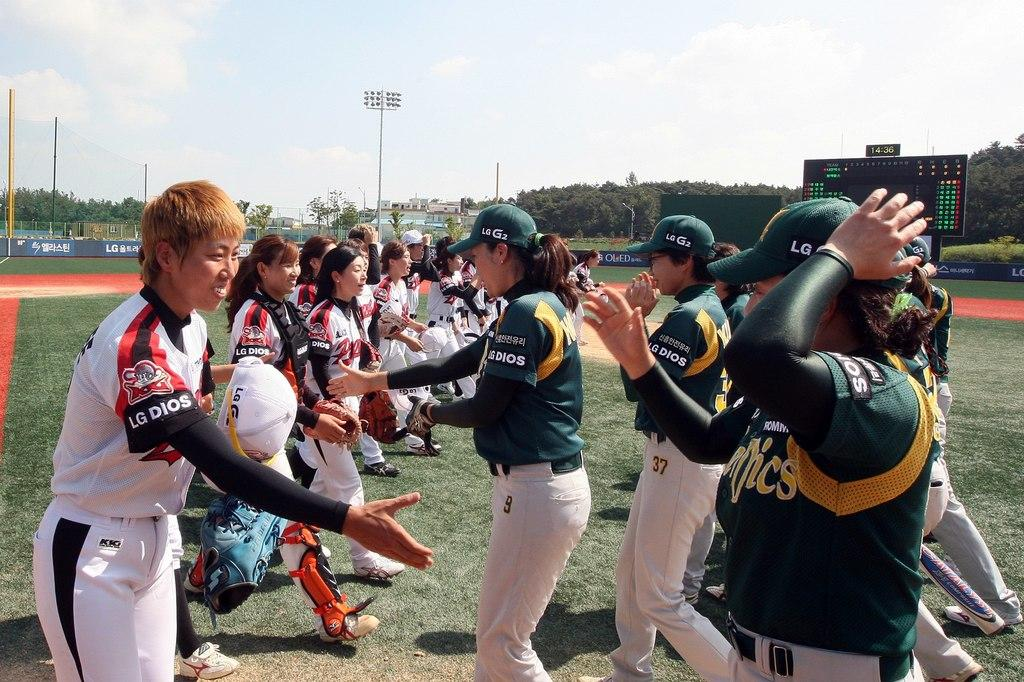Provide a one-sentence caption for the provided image. Two teams of women sports team on the field both wearing jersey with marking of LG DIOS. 